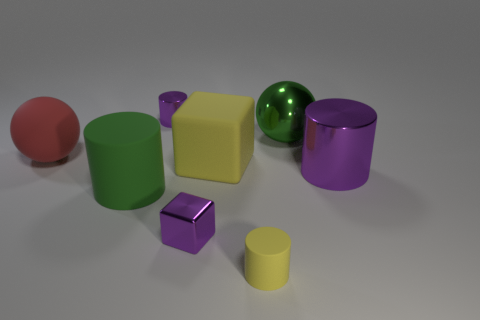Do the big rubber cylinder and the metallic sphere have the same color?
Your response must be concise. Yes. What number of things are matte cylinders behind the metallic block or purple metal things that are in front of the green matte thing?
Make the answer very short. 2. There is a purple object behind the red rubber object; what number of green balls are behind it?
Keep it short and to the point. 0. Is the shape of the green rubber object that is left of the small yellow cylinder the same as the large metallic thing behind the large red ball?
Your answer should be compact. No. There is a tiny object that is the same color as the small metallic cylinder; what shape is it?
Provide a short and direct response. Cube. Are there any small cubes made of the same material as the big block?
Keep it short and to the point. No. How many matte objects are big green objects or big things?
Your answer should be compact. 3. The small purple thing that is in front of the sphere on the right side of the large yellow block is what shape?
Your answer should be very brief. Cube. Are there fewer tiny cylinders on the right side of the small shiny cylinder than purple metal cylinders?
Provide a succinct answer. Yes. The big red thing has what shape?
Your answer should be very brief. Sphere. 